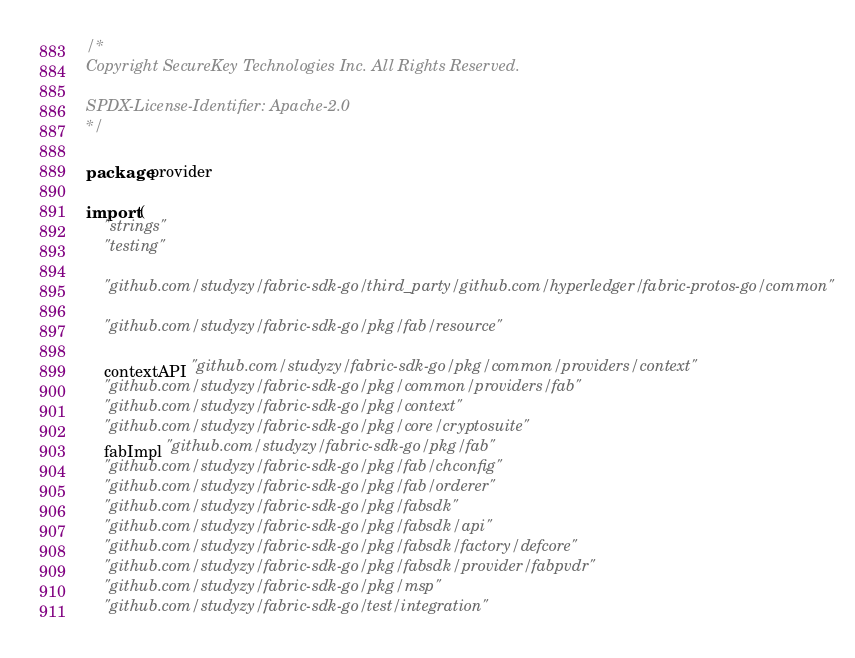<code> <loc_0><loc_0><loc_500><loc_500><_Go_>/*
Copyright SecureKey Technologies Inc. All Rights Reserved.

SPDX-License-Identifier: Apache-2.0
*/

package provider

import (
	"strings"
	"testing"

	"github.com/studyzy/fabric-sdk-go/third_party/github.com/hyperledger/fabric-protos-go/common"

	"github.com/studyzy/fabric-sdk-go/pkg/fab/resource"

	contextAPI "github.com/studyzy/fabric-sdk-go/pkg/common/providers/context"
	"github.com/studyzy/fabric-sdk-go/pkg/common/providers/fab"
	"github.com/studyzy/fabric-sdk-go/pkg/context"
	"github.com/studyzy/fabric-sdk-go/pkg/core/cryptosuite"
	fabImpl "github.com/studyzy/fabric-sdk-go/pkg/fab"
	"github.com/studyzy/fabric-sdk-go/pkg/fab/chconfig"
	"github.com/studyzy/fabric-sdk-go/pkg/fab/orderer"
	"github.com/studyzy/fabric-sdk-go/pkg/fabsdk"
	"github.com/studyzy/fabric-sdk-go/pkg/fabsdk/api"
	"github.com/studyzy/fabric-sdk-go/pkg/fabsdk/factory/defcore"
	"github.com/studyzy/fabric-sdk-go/pkg/fabsdk/provider/fabpvdr"
	"github.com/studyzy/fabric-sdk-go/pkg/msp"
	"github.com/studyzy/fabric-sdk-go/test/integration"</code> 